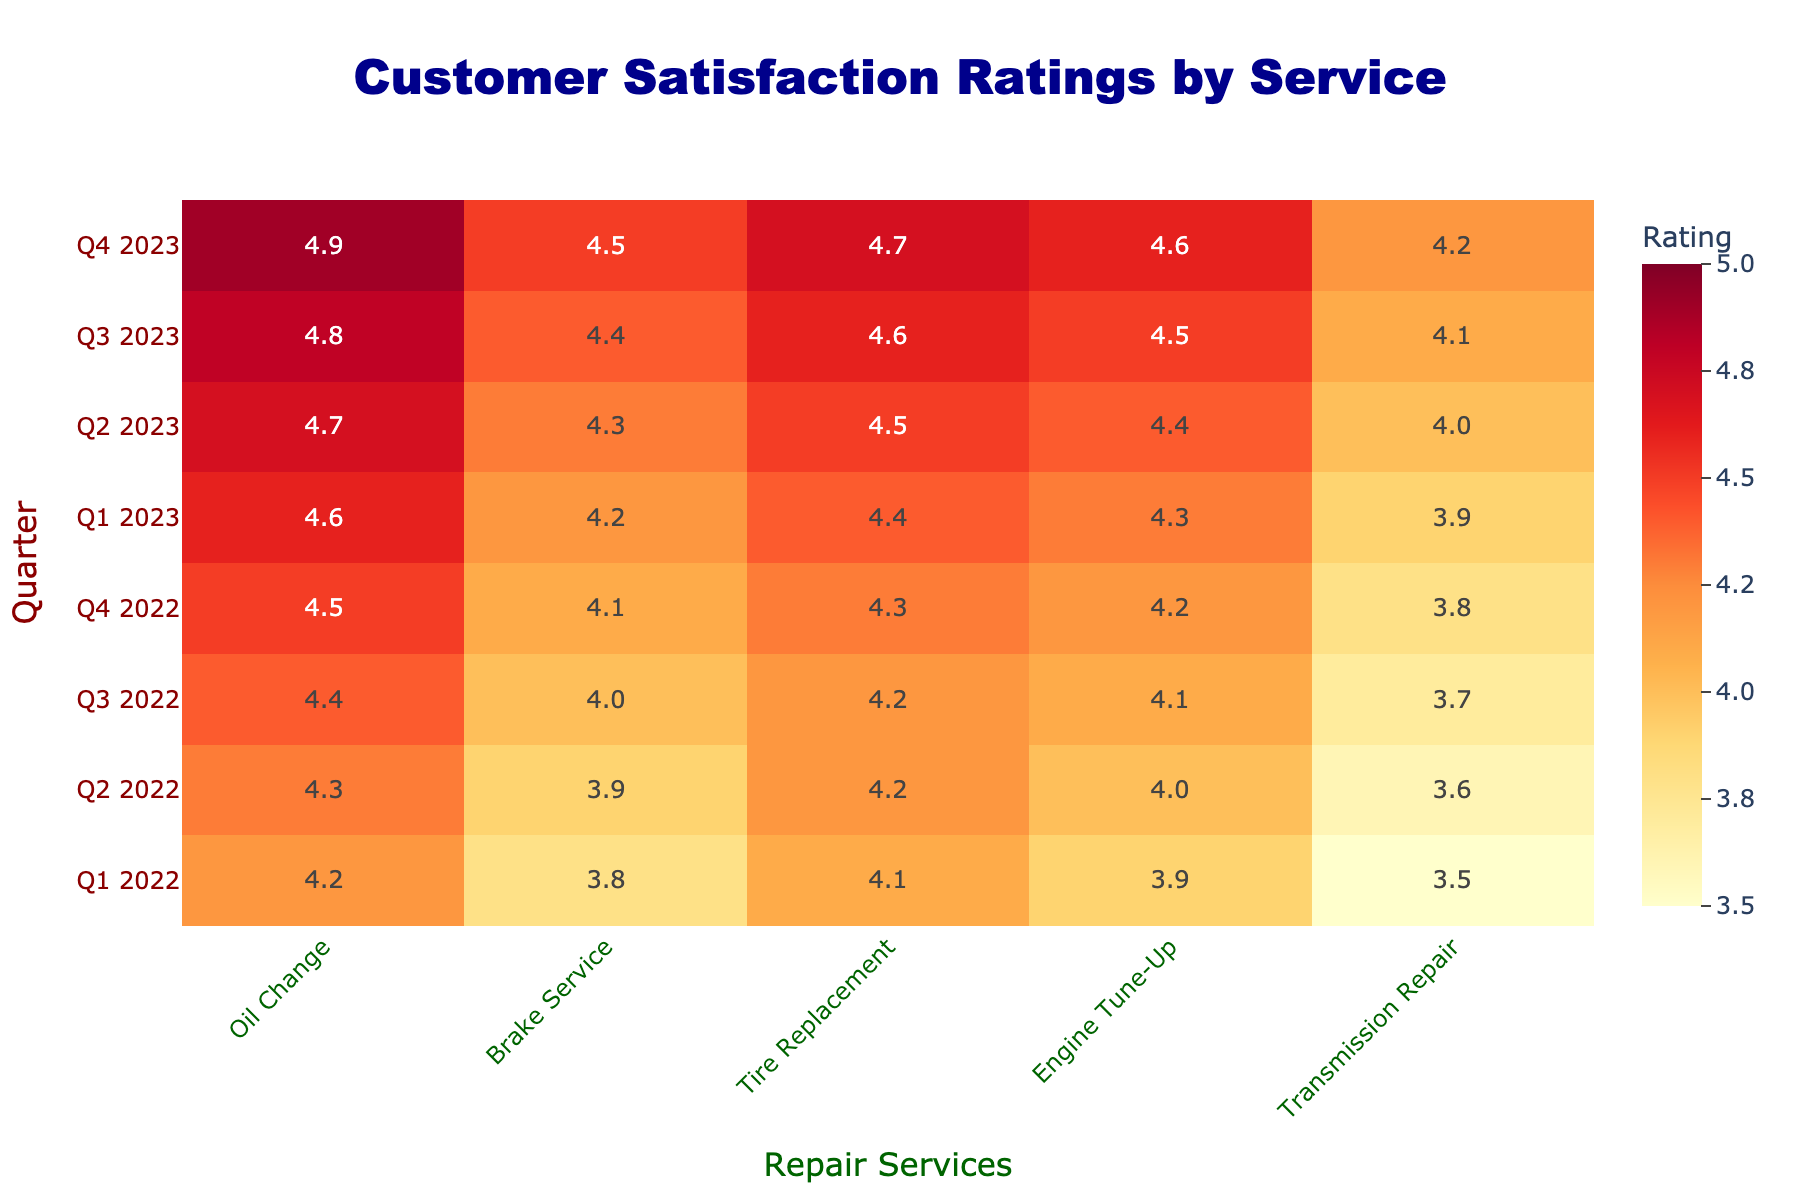What was the satisfaction rating for Brake Service in Q2 2023? From the table, you can find the rating for Brake Service under the Q2 2023 row. It shows a rating of 4.3.
Answer: 4.3 What was the highest satisfaction rating for Tire Replacement across all quarters? By checking the Tire Replacement column for each quarter, the highest rating observed is 4.7 in Q4 2023.
Answer: 4.7 Was there a decrease in satisfaction rating for Transmission Repair from Q3 2022 to Q4 2022? Checking the Transmission Repair ratings, Q3 2022 has a rating of 3.7 and Q4 2022 has a rating of 3.8. Since 3.8 is greater than 3.7, there was no decrease; instead, it increased.
Answer: No What is the difference in satisfaction ratings for Oil Change between Q1 2022 and Q4 2023? The Oil Change rating in Q1 2022 is 4.2, and in Q4 2023 it is 4.9. The difference is calculated as 4.9 - 4.2 = 0.7.
Answer: 0.7 Which repair service had the highest satisfaction rating in Q1 2022? In Q1 2022, the ratings for all services are as follows: Oil Change 4.2, Brake Service 3.8, Tire Replacement 4.1, Engine Tune-Up 3.9, and Transmission Repair 3.5. The highest among these is Oil Change at 4.2.
Answer: Oil Change What is the average satisfaction rating for Engine Tune-Up across all quarters? To calculate the average, sum the ratings for Engine Tune-Up over all quarters: (3.9 + 4.0 + 4.1 + 4.2 + 4.3 + 4.4 + 4.5 + 4.6) = 33.0. There are 8 quarters, so the average is 33.0 / 8 = 4.125.
Answer: 4.125 Did the satisfaction rating for Oil Change exceed 4.5 for all quarters starting from Q4 2022? For quarters starting from Q4 2022, the ratings for Oil Change are 4.5 (Q4 2022), 4.6 (Q1 2023), 4.7 (Q2 2023), 4.8 (Q3 2023), and 4.9 (Q4 2023). Since Q4 2022 is 4.5, it doesn't exceed 4.5 in that quarter.
Answer: No How does the satisfaction rating of Tire Replacement in Q3 2022 compare to Engine Tune-Up in the same quarter? Tire Replacement in Q3 2022 has a rating of 4.2, while Engine Tune-Up has a rating of 4.1. Comparing these, Tire Replacement (4.2) is higher than Engine Tune-Up (4.1).
Answer: Tire Replacement is higher 